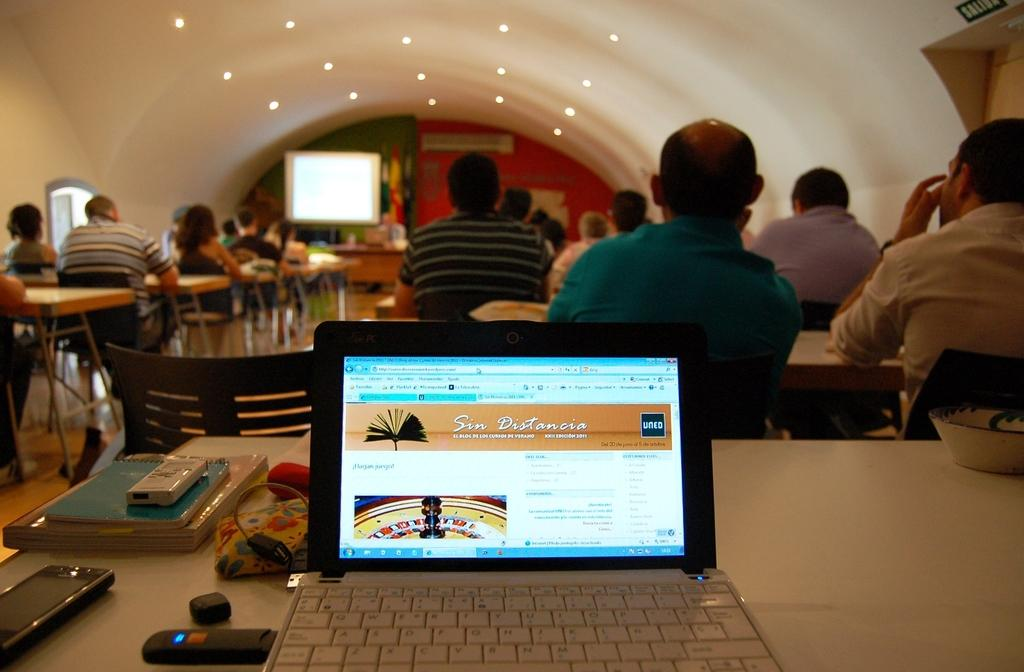What electronic device is visible in the image? There is a laptop in the image. What other electronic device can be seen in the image? There is a mobile in the image. What type of physical objects are present in the image? There are books in the image. Where are the objects located in the image? The objects are on a table. What are the people in the image doing? There are persons sitting on chairs. What is in the background of the image? There is a projector screen in the background of the image. What reason does the visitor have for being in the house in the image? There is no visitor present in the image, so it is not possible to determine the reason for their presence. 